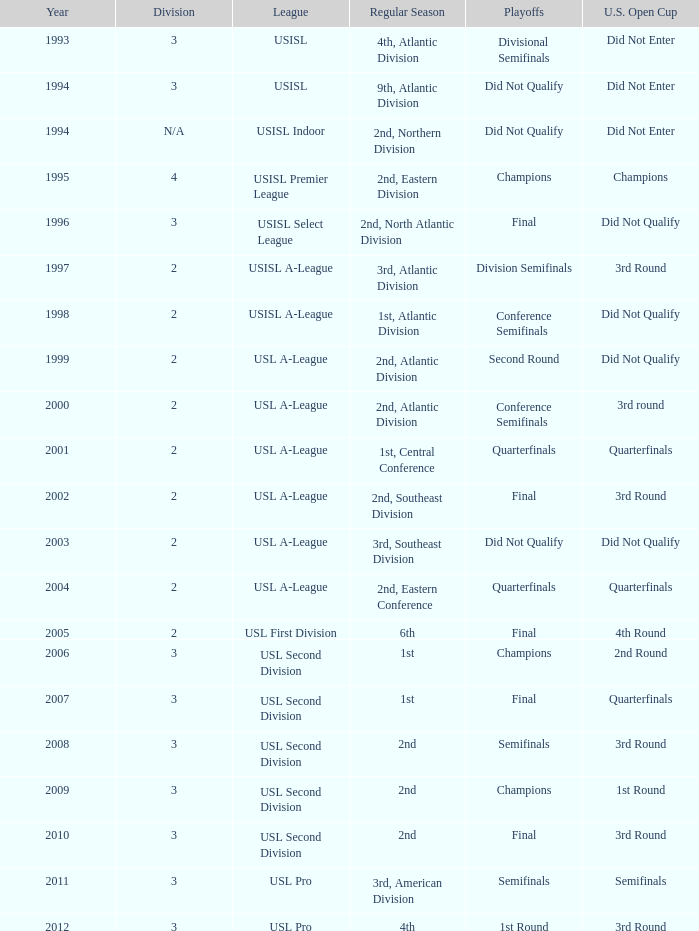What are all the playoffs for regular season is 1st, atlantic division Conference Semifinals. 